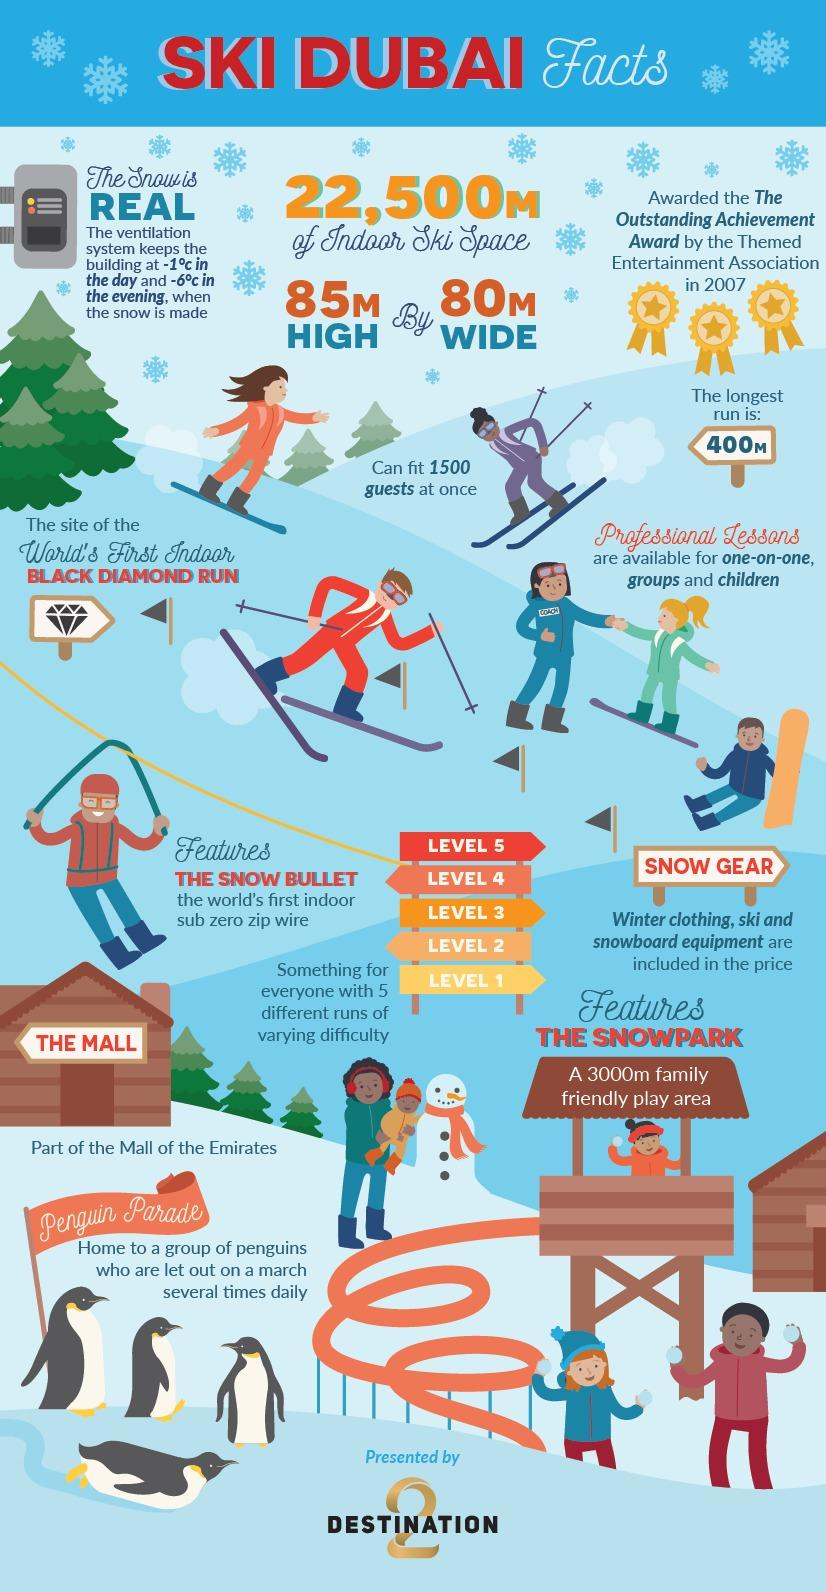List a handful of essential elements in this visual. The indoor ski area of Ski Dubai covers a total of 22,500 square meters. The longest run at Ski Dubai is approximately 400 meters. Ski Dubai can accommodate a maximum of 1500 guests at a time. 